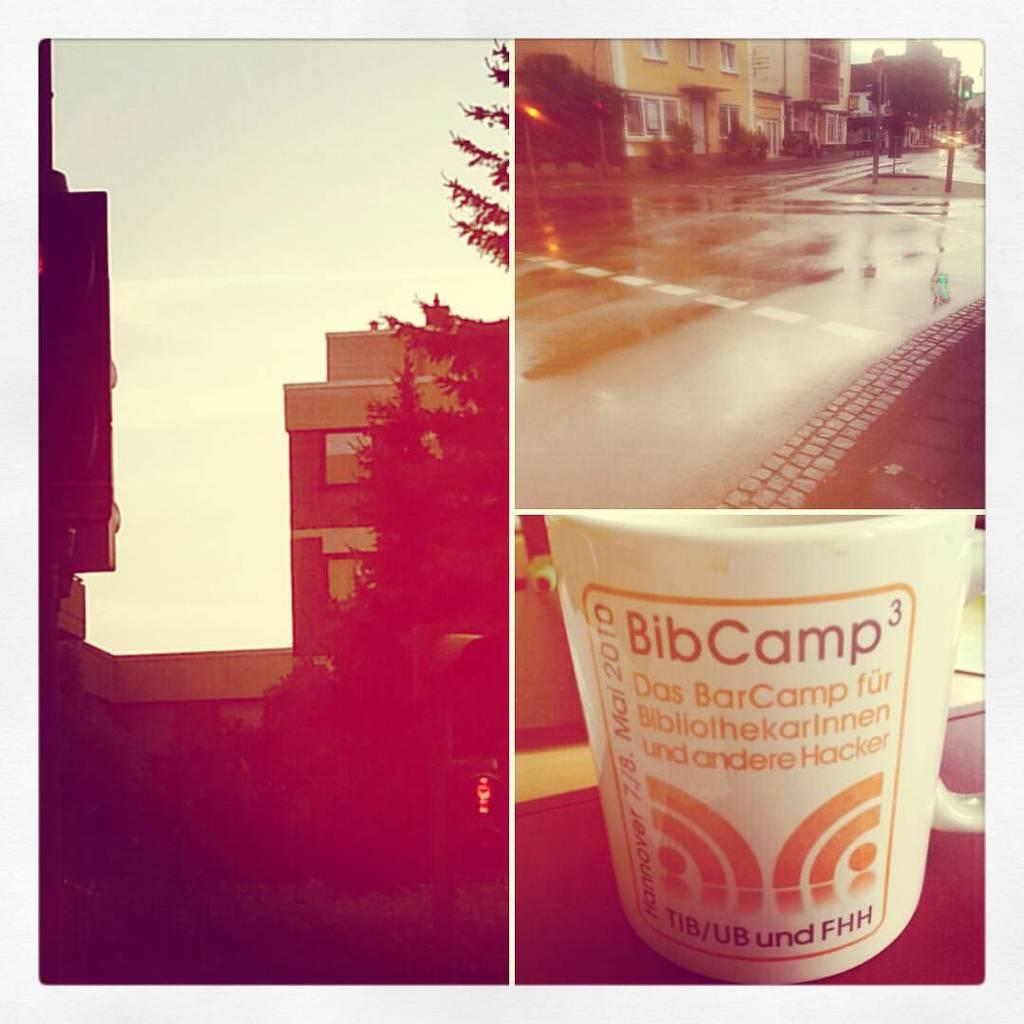<image>
Offer a succinct explanation of the picture presented. Several scenes include one of a container with the words Bib Camp at the top. 